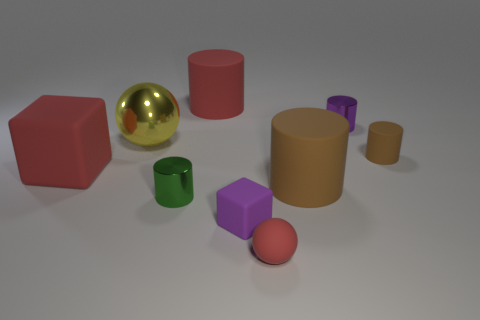Subtract all blue balls. How many brown cylinders are left? 2 Subtract all big cylinders. How many cylinders are left? 3 Subtract 2 cylinders. How many cylinders are left? 3 Subtract all red cylinders. How many cylinders are left? 4 Subtract all blocks. How many objects are left? 7 Add 1 red rubber things. How many objects exist? 10 Add 2 big red matte cylinders. How many big red matte cylinders exist? 3 Subtract 0 cyan balls. How many objects are left? 9 Subtract all green spheres. Subtract all red cylinders. How many spheres are left? 2 Subtract all brown rubber objects. Subtract all purple rubber blocks. How many objects are left? 6 